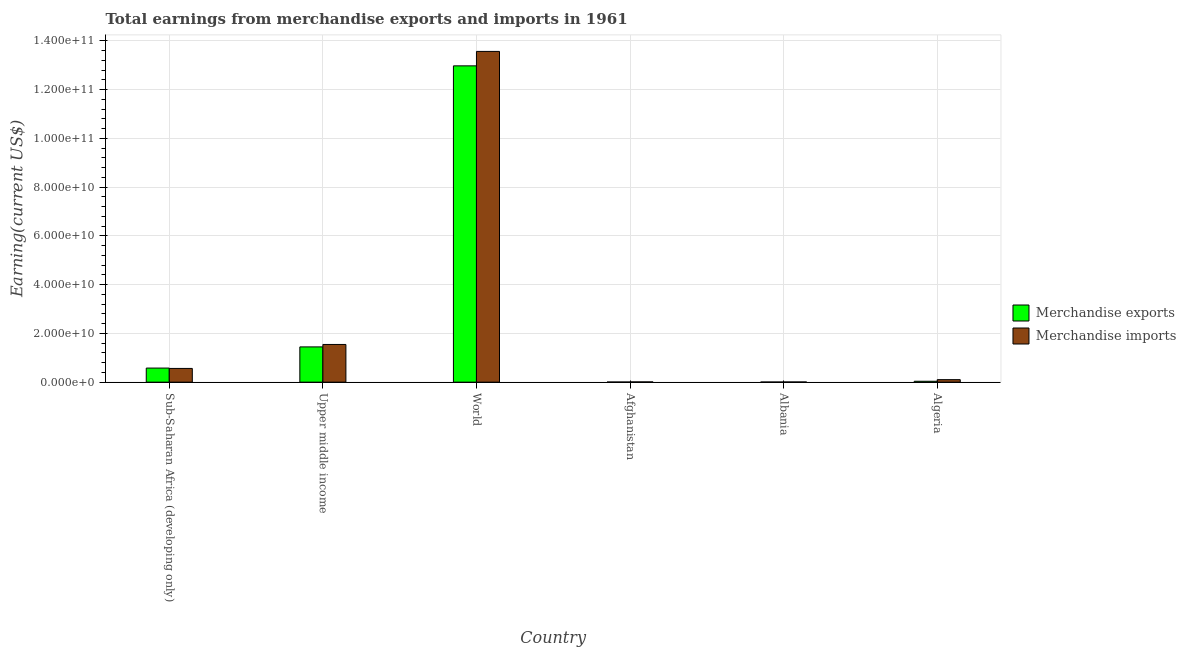How many groups of bars are there?
Keep it short and to the point. 6. Are the number of bars per tick equal to the number of legend labels?
Keep it short and to the point. Yes. Are the number of bars on each tick of the X-axis equal?
Give a very brief answer. Yes. How many bars are there on the 1st tick from the left?
Ensure brevity in your answer.  2. In how many cases, is the number of bars for a given country not equal to the number of legend labels?
Give a very brief answer. 0. What is the earnings from merchandise imports in Upper middle income?
Your response must be concise. 1.55e+1. Across all countries, what is the maximum earnings from merchandise imports?
Ensure brevity in your answer.  1.36e+11. Across all countries, what is the minimum earnings from merchandise exports?
Ensure brevity in your answer.  4.90e+07. In which country was the earnings from merchandise exports minimum?
Offer a very short reply. Albania. What is the total earnings from merchandise imports in the graph?
Give a very brief answer. 1.58e+11. What is the difference between the earnings from merchandise imports in Afghanistan and that in Sub-Saharan Africa (developing only)?
Your response must be concise. -5.53e+09. What is the difference between the earnings from merchandise imports in Algeria and the earnings from merchandise exports in Upper middle income?
Your answer should be compact. -1.34e+1. What is the average earnings from merchandise imports per country?
Your response must be concise. 2.63e+1. What is the difference between the earnings from merchandise imports and earnings from merchandise exports in Algeria?
Your answer should be compact. 6.56e+08. In how many countries, is the earnings from merchandise imports greater than 16000000000 US$?
Ensure brevity in your answer.  1. What is the ratio of the earnings from merchandise imports in Albania to that in Sub-Saharan Africa (developing only)?
Offer a very short reply. 0.01. Is the difference between the earnings from merchandise exports in Albania and World greater than the difference between the earnings from merchandise imports in Albania and World?
Give a very brief answer. Yes. What is the difference between the highest and the second highest earnings from merchandise exports?
Make the answer very short. 1.15e+11. What is the difference between the highest and the lowest earnings from merchandise exports?
Ensure brevity in your answer.  1.30e+11. What does the 1st bar from the left in Upper middle income represents?
Offer a very short reply. Merchandise exports. What does the 1st bar from the right in Upper middle income represents?
Your answer should be compact. Merchandise imports. How many bars are there?
Provide a succinct answer. 12. How many countries are there in the graph?
Your answer should be very brief. 6. What is the title of the graph?
Keep it short and to the point. Total earnings from merchandise exports and imports in 1961. Does "Non-pregnant women" appear as one of the legend labels in the graph?
Ensure brevity in your answer.  No. What is the label or title of the Y-axis?
Your answer should be very brief. Earning(current US$). What is the Earning(current US$) in Merchandise exports in Sub-Saharan Africa (developing only)?
Ensure brevity in your answer.  5.78e+09. What is the Earning(current US$) of Merchandise imports in Sub-Saharan Africa (developing only)?
Your answer should be compact. 5.63e+09. What is the Earning(current US$) of Merchandise exports in Upper middle income?
Your answer should be very brief. 1.45e+1. What is the Earning(current US$) of Merchandise imports in Upper middle income?
Provide a short and direct response. 1.55e+1. What is the Earning(current US$) of Merchandise exports in World?
Provide a short and direct response. 1.30e+11. What is the Earning(current US$) in Merchandise imports in World?
Your answer should be very brief. 1.36e+11. What is the Earning(current US$) of Merchandise exports in Afghanistan?
Your answer should be compact. 5.30e+07. What is the Earning(current US$) in Merchandise imports in Afghanistan?
Offer a terse response. 9.90e+07. What is the Earning(current US$) of Merchandise exports in Albania?
Ensure brevity in your answer.  4.90e+07. What is the Earning(current US$) in Merchandise imports in Albania?
Your answer should be very brief. 7.20e+07. What is the Earning(current US$) in Merchandise exports in Algeria?
Give a very brief answer. 3.67e+08. What is the Earning(current US$) of Merchandise imports in Algeria?
Provide a short and direct response. 1.02e+09. Across all countries, what is the maximum Earning(current US$) of Merchandise exports?
Offer a very short reply. 1.30e+11. Across all countries, what is the maximum Earning(current US$) in Merchandise imports?
Provide a succinct answer. 1.36e+11. Across all countries, what is the minimum Earning(current US$) in Merchandise exports?
Your answer should be very brief. 4.90e+07. Across all countries, what is the minimum Earning(current US$) in Merchandise imports?
Your response must be concise. 7.20e+07. What is the total Earning(current US$) in Merchandise exports in the graph?
Your answer should be compact. 1.51e+11. What is the total Earning(current US$) of Merchandise imports in the graph?
Your answer should be very brief. 1.58e+11. What is the difference between the Earning(current US$) of Merchandise exports in Sub-Saharan Africa (developing only) and that in Upper middle income?
Provide a short and direct response. -8.69e+09. What is the difference between the Earning(current US$) of Merchandise imports in Sub-Saharan Africa (developing only) and that in Upper middle income?
Offer a very short reply. -9.84e+09. What is the difference between the Earning(current US$) in Merchandise exports in Sub-Saharan Africa (developing only) and that in World?
Provide a short and direct response. -1.24e+11. What is the difference between the Earning(current US$) in Merchandise imports in Sub-Saharan Africa (developing only) and that in World?
Your answer should be compact. -1.30e+11. What is the difference between the Earning(current US$) in Merchandise exports in Sub-Saharan Africa (developing only) and that in Afghanistan?
Your answer should be compact. 5.72e+09. What is the difference between the Earning(current US$) in Merchandise imports in Sub-Saharan Africa (developing only) and that in Afghanistan?
Give a very brief answer. 5.53e+09. What is the difference between the Earning(current US$) in Merchandise exports in Sub-Saharan Africa (developing only) and that in Albania?
Make the answer very short. 5.73e+09. What is the difference between the Earning(current US$) in Merchandise imports in Sub-Saharan Africa (developing only) and that in Albania?
Your answer should be compact. 5.56e+09. What is the difference between the Earning(current US$) in Merchandise exports in Sub-Saharan Africa (developing only) and that in Algeria?
Offer a very short reply. 5.41e+09. What is the difference between the Earning(current US$) of Merchandise imports in Sub-Saharan Africa (developing only) and that in Algeria?
Provide a succinct answer. 4.61e+09. What is the difference between the Earning(current US$) of Merchandise exports in Upper middle income and that in World?
Provide a succinct answer. -1.15e+11. What is the difference between the Earning(current US$) in Merchandise imports in Upper middle income and that in World?
Offer a very short reply. -1.20e+11. What is the difference between the Earning(current US$) in Merchandise exports in Upper middle income and that in Afghanistan?
Your answer should be compact. 1.44e+1. What is the difference between the Earning(current US$) of Merchandise imports in Upper middle income and that in Afghanistan?
Give a very brief answer. 1.54e+1. What is the difference between the Earning(current US$) in Merchandise exports in Upper middle income and that in Albania?
Your response must be concise. 1.44e+1. What is the difference between the Earning(current US$) in Merchandise imports in Upper middle income and that in Albania?
Provide a succinct answer. 1.54e+1. What is the difference between the Earning(current US$) in Merchandise exports in Upper middle income and that in Algeria?
Ensure brevity in your answer.  1.41e+1. What is the difference between the Earning(current US$) of Merchandise imports in Upper middle income and that in Algeria?
Provide a short and direct response. 1.44e+1. What is the difference between the Earning(current US$) in Merchandise exports in World and that in Afghanistan?
Your answer should be compact. 1.30e+11. What is the difference between the Earning(current US$) of Merchandise imports in World and that in Afghanistan?
Keep it short and to the point. 1.36e+11. What is the difference between the Earning(current US$) of Merchandise exports in World and that in Albania?
Offer a very short reply. 1.30e+11. What is the difference between the Earning(current US$) of Merchandise imports in World and that in Albania?
Your answer should be very brief. 1.36e+11. What is the difference between the Earning(current US$) of Merchandise exports in World and that in Algeria?
Ensure brevity in your answer.  1.29e+11. What is the difference between the Earning(current US$) in Merchandise imports in World and that in Algeria?
Your response must be concise. 1.35e+11. What is the difference between the Earning(current US$) of Merchandise exports in Afghanistan and that in Albania?
Provide a short and direct response. 4.00e+06. What is the difference between the Earning(current US$) in Merchandise imports in Afghanistan and that in Albania?
Offer a very short reply. 2.70e+07. What is the difference between the Earning(current US$) of Merchandise exports in Afghanistan and that in Algeria?
Offer a terse response. -3.14e+08. What is the difference between the Earning(current US$) of Merchandise imports in Afghanistan and that in Algeria?
Keep it short and to the point. -9.25e+08. What is the difference between the Earning(current US$) in Merchandise exports in Albania and that in Algeria?
Provide a short and direct response. -3.18e+08. What is the difference between the Earning(current US$) in Merchandise imports in Albania and that in Algeria?
Ensure brevity in your answer.  -9.52e+08. What is the difference between the Earning(current US$) in Merchandise exports in Sub-Saharan Africa (developing only) and the Earning(current US$) in Merchandise imports in Upper middle income?
Your response must be concise. -9.69e+09. What is the difference between the Earning(current US$) of Merchandise exports in Sub-Saharan Africa (developing only) and the Earning(current US$) of Merchandise imports in World?
Ensure brevity in your answer.  -1.30e+11. What is the difference between the Earning(current US$) in Merchandise exports in Sub-Saharan Africa (developing only) and the Earning(current US$) in Merchandise imports in Afghanistan?
Give a very brief answer. 5.68e+09. What is the difference between the Earning(current US$) in Merchandise exports in Sub-Saharan Africa (developing only) and the Earning(current US$) in Merchandise imports in Albania?
Offer a terse response. 5.70e+09. What is the difference between the Earning(current US$) in Merchandise exports in Sub-Saharan Africa (developing only) and the Earning(current US$) in Merchandise imports in Algeria?
Provide a succinct answer. 4.75e+09. What is the difference between the Earning(current US$) in Merchandise exports in Upper middle income and the Earning(current US$) in Merchandise imports in World?
Keep it short and to the point. -1.21e+11. What is the difference between the Earning(current US$) of Merchandise exports in Upper middle income and the Earning(current US$) of Merchandise imports in Afghanistan?
Provide a succinct answer. 1.44e+1. What is the difference between the Earning(current US$) in Merchandise exports in Upper middle income and the Earning(current US$) in Merchandise imports in Albania?
Ensure brevity in your answer.  1.44e+1. What is the difference between the Earning(current US$) of Merchandise exports in Upper middle income and the Earning(current US$) of Merchandise imports in Algeria?
Ensure brevity in your answer.  1.34e+1. What is the difference between the Earning(current US$) in Merchandise exports in World and the Earning(current US$) in Merchandise imports in Afghanistan?
Offer a terse response. 1.30e+11. What is the difference between the Earning(current US$) of Merchandise exports in World and the Earning(current US$) of Merchandise imports in Albania?
Give a very brief answer. 1.30e+11. What is the difference between the Earning(current US$) of Merchandise exports in World and the Earning(current US$) of Merchandise imports in Algeria?
Offer a very short reply. 1.29e+11. What is the difference between the Earning(current US$) in Merchandise exports in Afghanistan and the Earning(current US$) in Merchandise imports in Albania?
Offer a very short reply. -1.90e+07. What is the difference between the Earning(current US$) in Merchandise exports in Afghanistan and the Earning(current US$) in Merchandise imports in Algeria?
Provide a short and direct response. -9.71e+08. What is the difference between the Earning(current US$) of Merchandise exports in Albania and the Earning(current US$) of Merchandise imports in Algeria?
Ensure brevity in your answer.  -9.75e+08. What is the average Earning(current US$) of Merchandise exports per country?
Provide a short and direct response. 2.51e+1. What is the average Earning(current US$) of Merchandise imports per country?
Make the answer very short. 2.63e+1. What is the difference between the Earning(current US$) in Merchandise exports and Earning(current US$) in Merchandise imports in Sub-Saharan Africa (developing only)?
Your answer should be very brief. 1.45e+08. What is the difference between the Earning(current US$) of Merchandise exports and Earning(current US$) of Merchandise imports in Upper middle income?
Make the answer very short. -1.00e+09. What is the difference between the Earning(current US$) in Merchandise exports and Earning(current US$) in Merchandise imports in World?
Provide a succinct answer. -5.93e+09. What is the difference between the Earning(current US$) in Merchandise exports and Earning(current US$) in Merchandise imports in Afghanistan?
Offer a terse response. -4.60e+07. What is the difference between the Earning(current US$) in Merchandise exports and Earning(current US$) in Merchandise imports in Albania?
Keep it short and to the point. -2.30e+07. What is the difference between the Earning(current US$) in Merchandise exports and Earning(current US$) in Merchandise imports in Algeria?
Provide a succinct answer. -6.56e+08. What is the ratio of the Earning(current US$) in Merchandise exports in Sub-Saharan Africa (developing only) to that in Upper middle income?
Give a very brief answer. 0.4. What is the ratio of the Earning(current US$) in Merchandise imports in Sub-Saharan Africa (developing only) to that in Upper middle income?
Offer a very short reply. 0.36. What is the ratio of the Earning(current US$) of Merchandise exports in Sub-Saharan Africa (developing only) to that in World?
Ensure brevity in your answer.  0.04. What is the ratio of the Earning(current US$) of Merchandise imports in Sub-Saharan Africa (developing only) to that in World?
Your response must be concise. 0.04. What is the ratio of the Earning(current US$) in Merchandise exports in Sub-Saharan Africa (developing only) to that in Afghanistan?
Offer a very short reply. 108.97. What is the ratio of the Earning(current US$) in Merchandise imports in Sub-Saharan Africa (developing only) to that in Afghanistan?
Provide a succinct answer. 56.87. What is the ratio of the Earning(current US$) in Merchandise exports in Sub-Saharan Africa (developing only) to that in Albania?
Your answer should be very brief. 117.87. What is the ratio of the Earning(current US$) of Merchandise imports in Sub-Saharan Africa (developing only) to that in Albania?
Provide a short and direct response. 78.2. What is the ratio of the Earning(current US$) in Merchandise exports in Sub-Saharan Africa (developing only) to that in Algeria?
Provide a short and direct response. 15.72. What is the ratio of the Earning(current US$) in Merchandise imports in Sub-Saharan Africa (developing only) to that in Algeria?
Provide a short and direct response. 5.5. What is the ratio of the Earning(current US$) in Merchandise exports in Upper middle income to that in World?
Your response must be concise. 0.11. What is the ratio of the Earning(current US$) of Merchandise imports in Upper middle income to that in World?
Give a very brief answer. 0.11. What is the ratio of the Earning(current US$) in Merchandise exports in Upper middle income to that in Afghanistan?
Offer a terse response. 272.98. What is the ratio of the Earning(current US$) of Merchandise imports in Upper middle income to that in Afghanistan?
Give a very brief answer. 156.24. What is the ratio of the Earning(current US$) in Merchandise exports in Upper middle income to that in Albania?
Provide a succinct answer. 295.26. What is the ratio of the Earning(current US$) in Merchandise imports in Upper middle income to that in Albania?
Provide a succinct answer. 214.84. What is the ratio of the Earning(current US$) of Merchandise exports in Upper middle income to that in Algeria?
Make the answer very short. 39.38. What is the ratio of the Earning(current US$) in Merchandise imports in Upper middle income to that in Algeria?
Give a very brief answer. 15.11. What is the ratio of the Earning(current US$) of Merchandise exports in World to that in Afghanistan?
Offer a very short reply. 2448.95. What is the ratio of the Earning(current US$) in Merchandise imports in World to that in Afghanistan?
Provide a short and direct response. 1370.93. What is the ratio of the Earning(current US$) of Merchandise exports in World to that in Albania?
Your answer should be very brief. 2648.86. What is the ratio of the Earning(current US$) in Merchandise imports in World to that in Albania?
Ensure brevity in your answer.  1885.04. What is the ratio of the Earning(current US$) in Merchandise exports in World to that in Algeria?
Provide a short and direct response. 353.25. What is the ratio of the Earning(current US$) of Merchandise imports in World to that in Algeria?
Your answer should be compact. 132.56. What is the ratio of the Earning(current US$) in Merchandise exports in Afghanistan to that in Albania?
Provide a succinct answer. 1.08. What is the ratio of the Earning(current US$) of Merchandise imports in Afghanistan to that in Albania?
Your answer should be compact. 1.38. What is the ratio of the Earning(current US$) in Merchandise exports in Afghanistan to that in Algeria?
Give a very brief answer. 0.14. What is the ratio of the Earning(current US$) in Merchandise imports in Afghanistan to that in Algeria?
Offer a terse response. 0.1. What is the ratio of the Earning(current US$) of Merchandise exports in Albania to that in Algeria?
Make the answer very short. 0.13. What is the ratio of the Earning(current US$) of Merchandise imports in Albania to that in Algeria?
Ensure brevity in your answer.  0.07. What is the difference between the highest and the second highest Earning(current US$) of Merchandise exports?
Provide a succinct answer. 1.15e+11. What is the difference between the highest and the second highest Earning(current US$) in Merchandise imports?
Provide a short and direct response. 1.20e+11. What is the difference between the highest and the lowest Earning(current US$) of Merchandise exports?
Keep it short and to the point. 1.30e+11. What is the difference between the highest and the lowest Earning(current US$) of Merchandise imports?
Provide a succinct answer. 1.36e+11. 